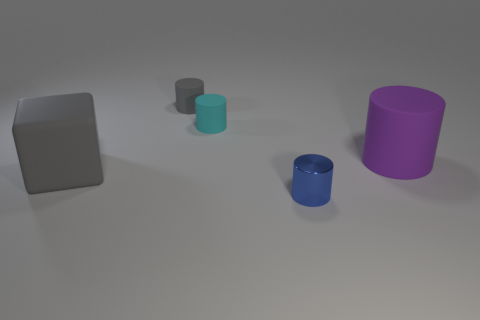Are there any gray blocks that have the same size as the purple cylinder?
Your answer should be compact. Yes. There is a gray object behind the matte object that is on the right side of the cylinder that is in front of the rubber block; what is it made of?
Keep it short and to the point. Rubber. Are there an equal number of cyan rubber things right of the large purple cylinder and small yellow matte blocks?
Provide a short and direct response. Yes. Is the gray object behind the block made of the same material as the object that is on the right side of the small blue metal thing?
Keep it short and to the point. Yes. How many things are large purple metal cylinders or big things that are to the left of the gray cylinder?
Offer a terse response. 1. Is there another object of the same shape as the tiny gray object?
Provide a succinct answer. Yes. How big is the rubber object in front of the rubber cylinder that is in front of the small matte cylinder in front of the gray cylinder?
Provide a short and direct response. Large. Is the number of purple rubber cylinders that are behind the large purple thing the same as the number of small matte cylinders that are to the right of the cyan cylinder?
Your response must be concise. Yes. There is a cyan cylinder that is the same material as the cube; what size is it?
Keep it short and to the point. Small. The tiny metal object is what color?
Your answer should be very brief. Blue. 